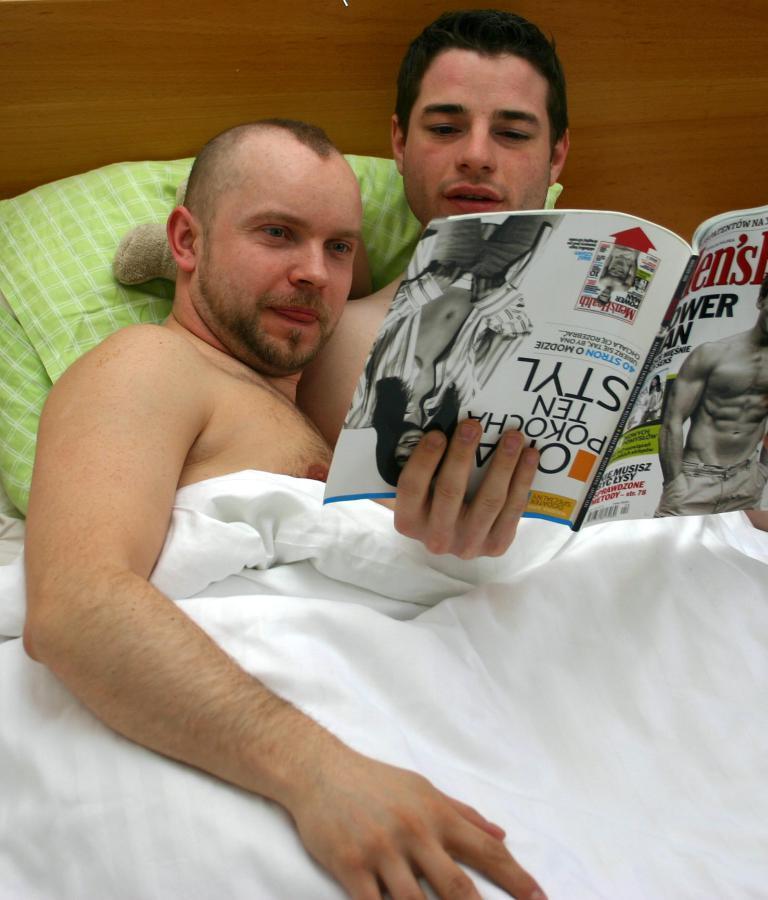Describe this image in one or two sentences. This picture seems to be clicked inside. On the left there is a man lying on the bed. In the foreground we can see a white color blanket. On the right there is another man lying on the bed and holding a book and we can see the text and pictures of persons on the top of the book. In the background there is a wall. 